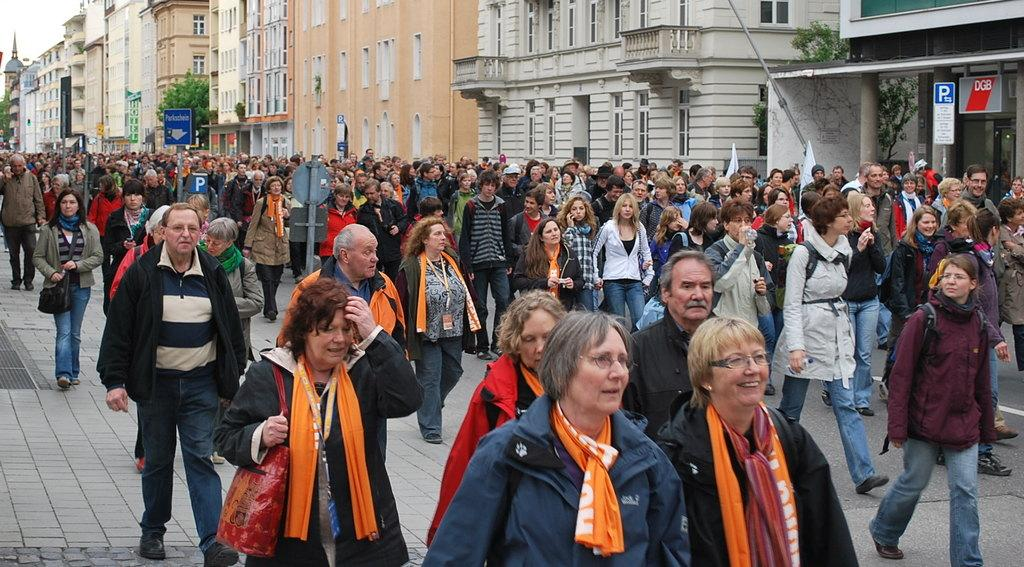What are the people in the image doing? The people in the image are walking on the road. What can be seen in the background of the image? There are buildings, poles, and trees in the background of the image. Where is the shop located in the image? There is no shop present in the image. Can you describe the curve of the road in the image? There is no curve in the road visible in the image; it appears to be a straight road. 